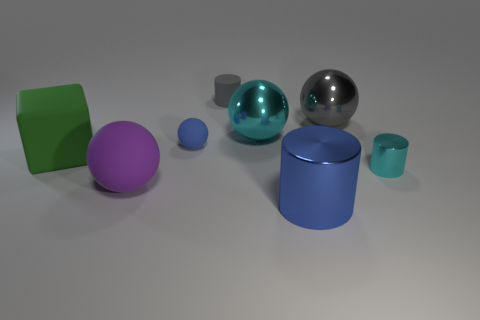Add 2 tiny yellow matte cylinders. How many objects exist? 10 Subtract all cylinders. How many objects are left? 5 Add 5 big cylinders. How many big cylinders exist? 6 Subtract 0 brown cylinders. How many objects are left? 8 Subtract all cyan cylinders. Subtract all large red rubber things. How many objects are left? 7 Add 5 small blue matte objects. How many small blue matte objects are left? 6 